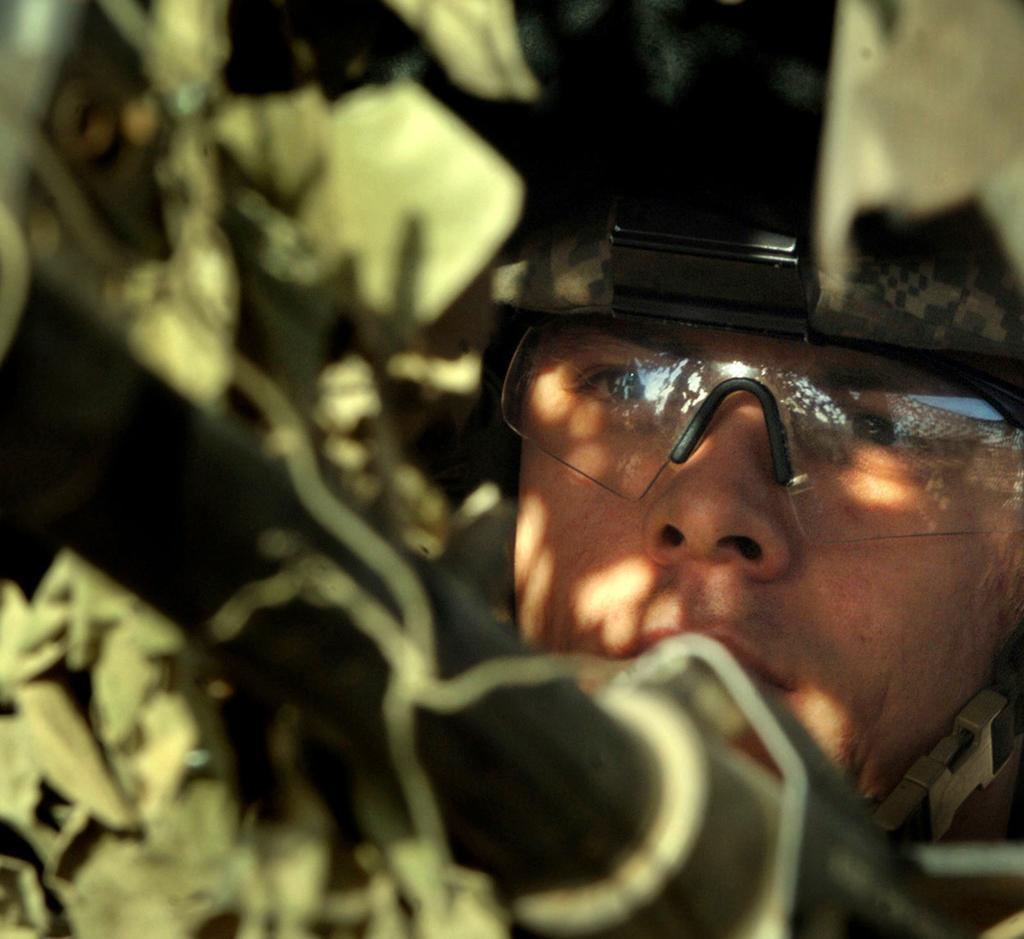Describe this image in one or two sentences. In this image there is a man, he is wearing goggles, he is wearing a helmet, there are objects towards the top of the image, there are objects towards the bottom of the image. 